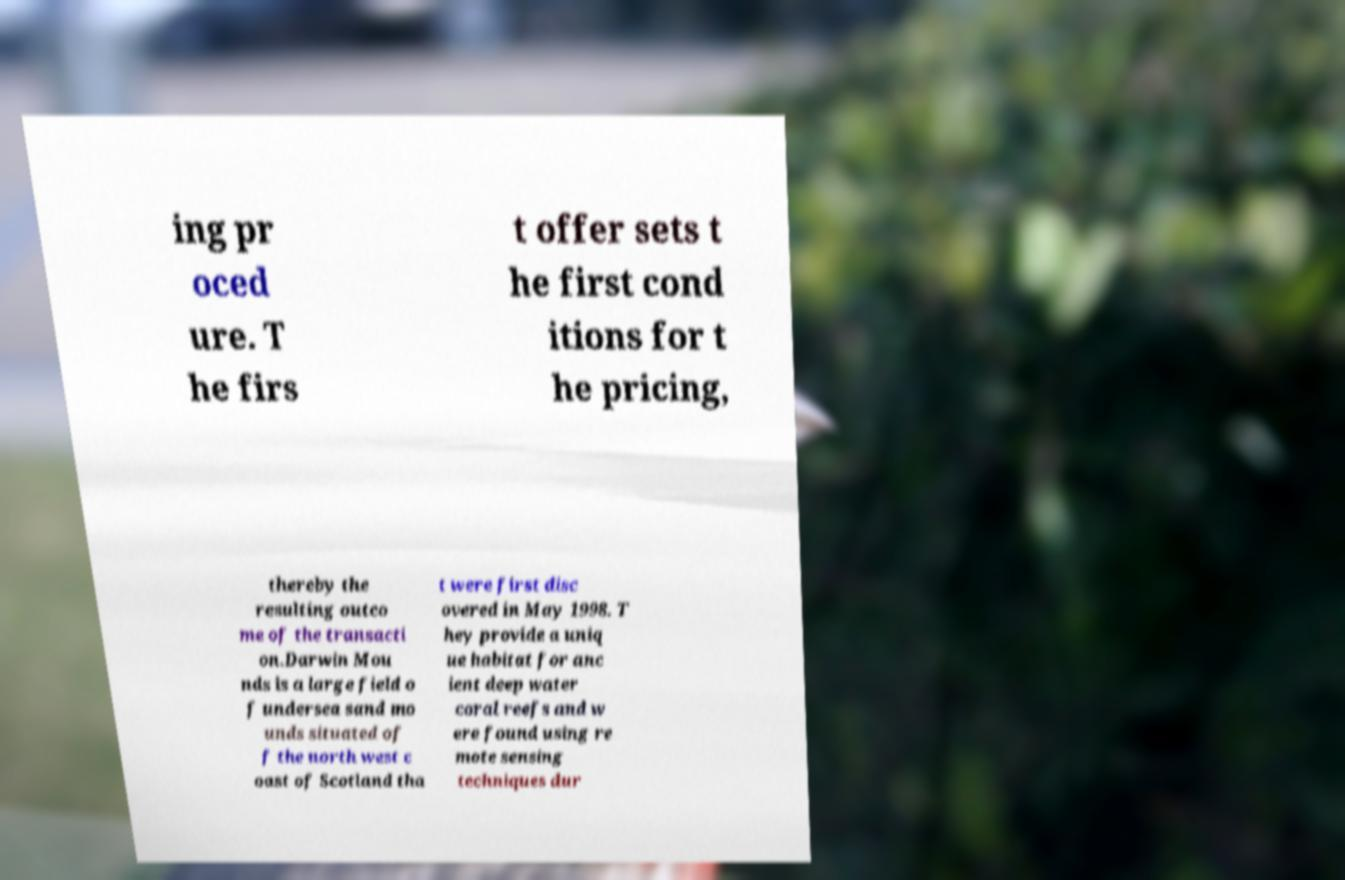Please read and relay the text visible in this image. What does it say? ing pr oced ure. T he firs t offer sets t he first cond itions for t he pricing, thereby the resulting outco me of the transacti on.Darwin Mou nds is a large field o f undersea sand mo unds situated of f the north west c oast of Scotland tha t were first disc overed in May 1998. T hey provide a uniq ue habitat for anc ient deep water coral reefs and w ere found using re mote sensing techniques dur 